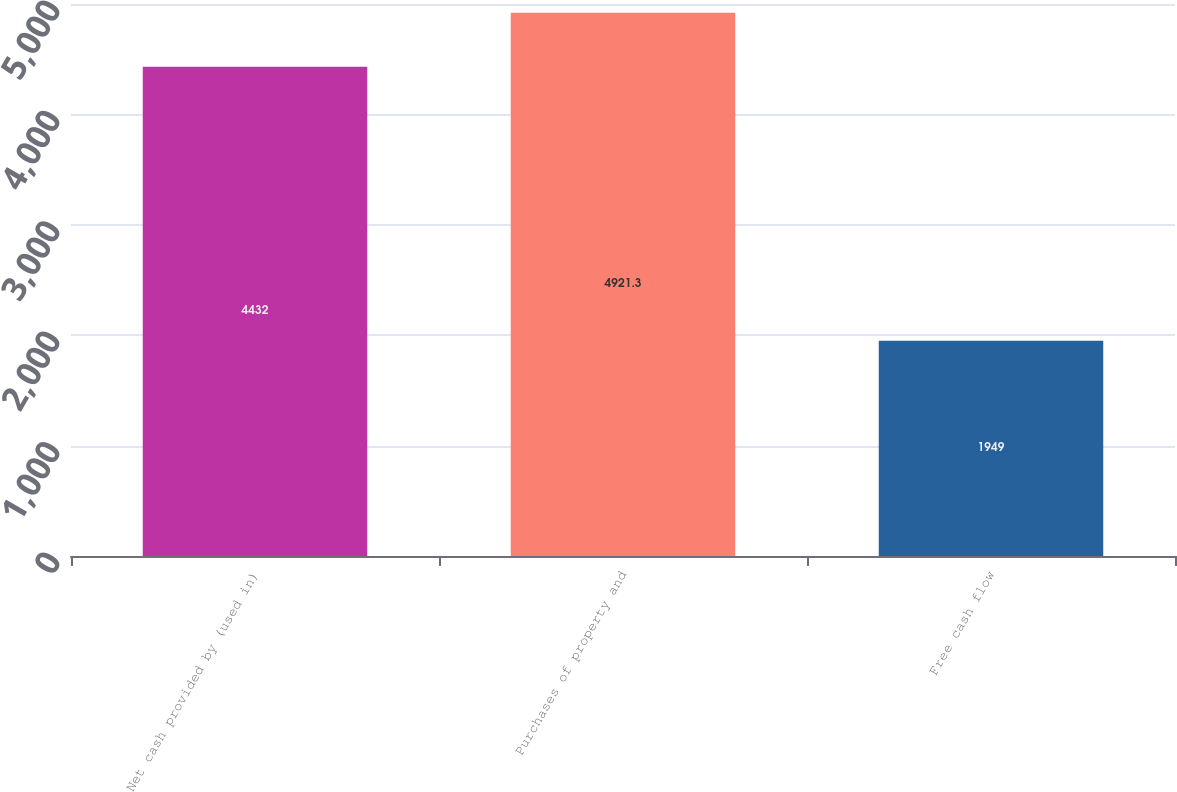<chart> <loc_0><loc_0><loc_500><loc_500><bar_chart><fcel>Net cash provided by (used in)<fcel>Purchases of property and<fcel>Free cash flow<nl><fcel>4432<fcel>4921.3<fcel>1949<nl></chart> 